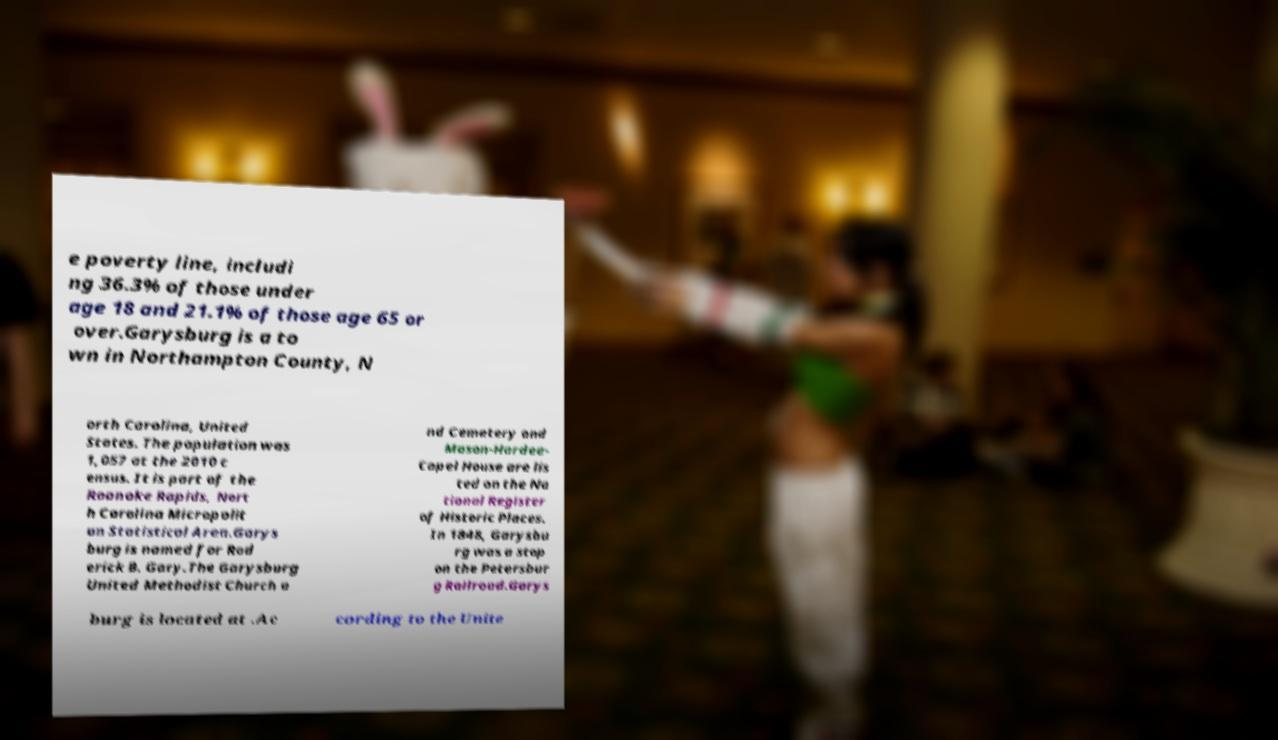Could you extract and type out the text from this image? e poverty line, includi ng 36.3% of those under age 18 and 21.1% of those age 65 or over.Garysburg is a to wn in Northampton County, N orth Carolina, United States. The population was 1,057 at the 2010 c ensus. It is part of the Roanoke Rapids, Nort h Carolina Micropolit an Statistical Area.Garys burg is named for Rod erick B. Gary.The Garysburg United Methodist Church a nd Cemetery and Mason-Hardee- Capel House are lis ted on the Na tional Register of Historic Places. In 1848, Garysbu rg was a stop on the Petersbur g Railroad.Garys burg is located at .Ac cording to the Unite 